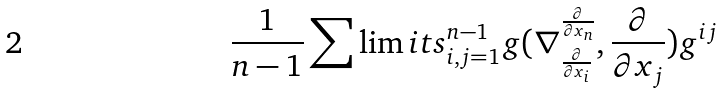Convert formula to latex. <formula><loc_0><loc_0><loc_500><loc_500>\frac { 1 } { n - 1 } \sum \lim i t s _ { i , j = 1 } ^ { n - 1 } g ( \nabla _ { \frac { \partial } { \partial x _ { i } } } ^ { \frac { \partial } { \partial x _ { n } } } , \frac { \partial } { \partial x _ { j } } ) g ^ { i j }</formula> 